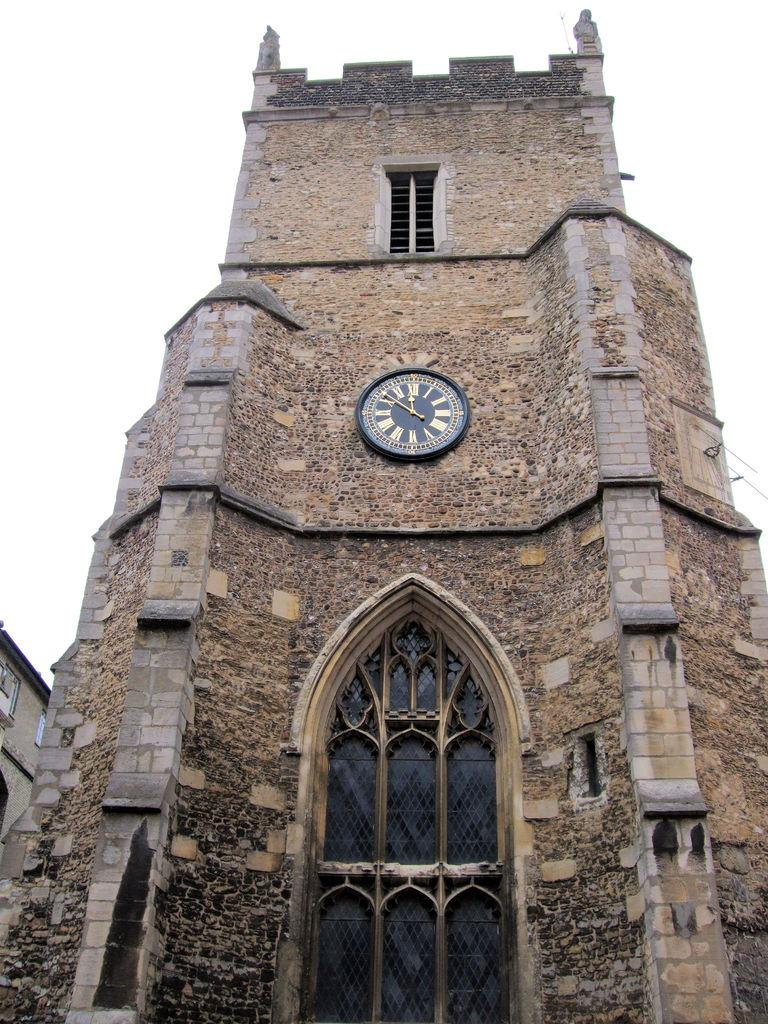<image>
Render a clear and concise summary of the photo. A clock on a cobblestone cathedral showing that it is eight minutes til noon. 